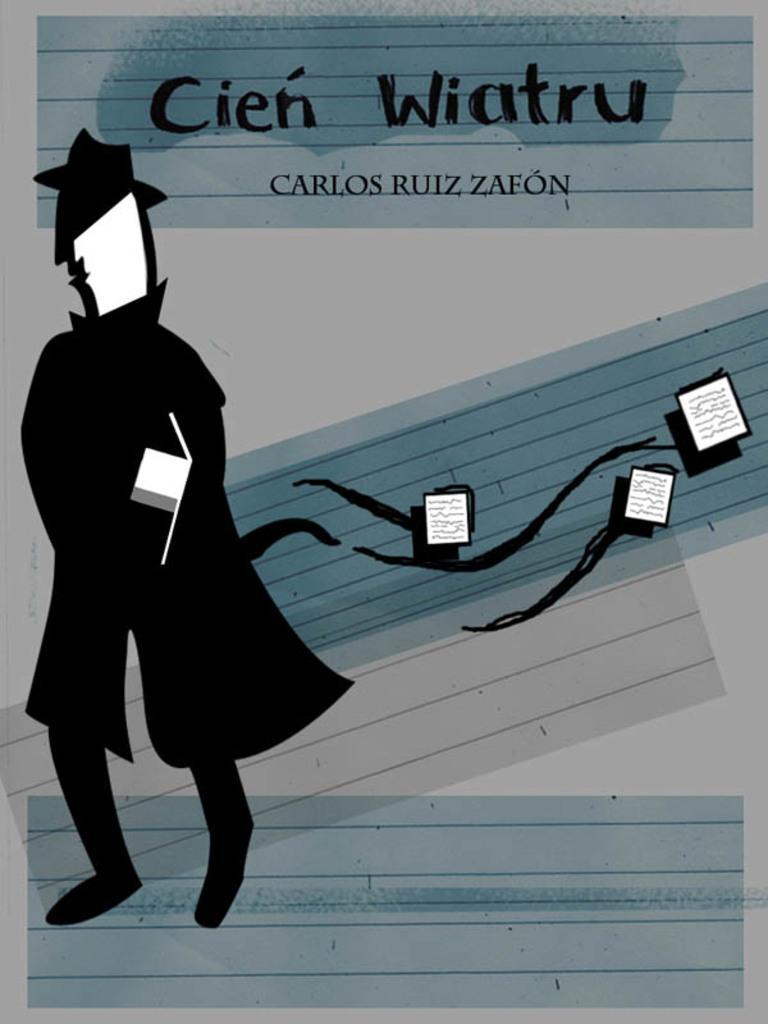How would you summarize this image in a sentence or two? In this image we can see a poster with some text and picture. 